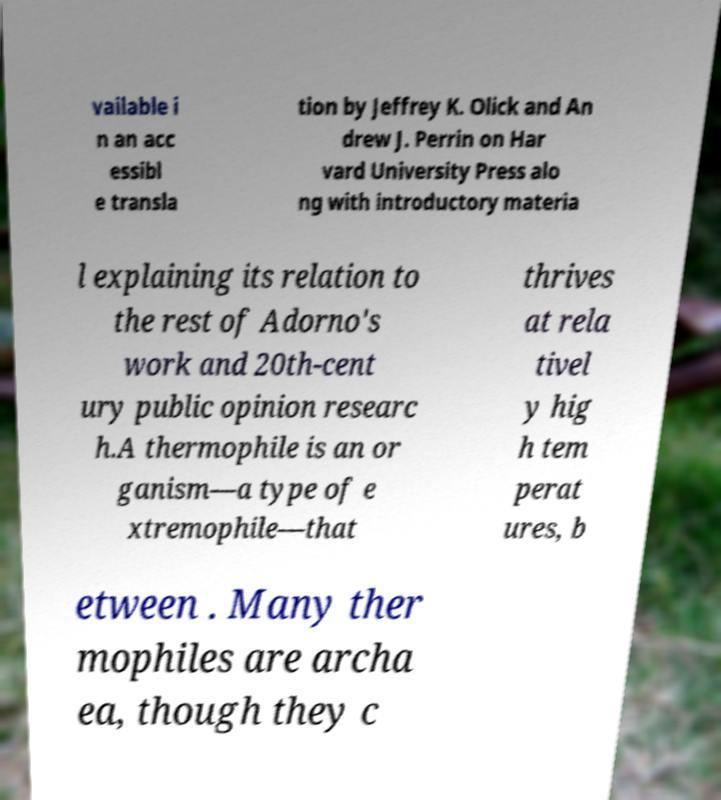What messages or text are displayed in this image? I need them in a readable, typed format. vailable i n an acc essibl e transla tion by Jeffrey K. Olick and An drew J. Perrin on Har vard University Press alo ng with introductory materia l explaining its relation to the rest of Adorno's work and 20th-cent ury public opinion researc h.A thermophile is an or ganism—a type of e xtremophile—that thrives at rela tivel y hig h tem perat ures, b etween . Many ther mophiles are archa ea, though they c 